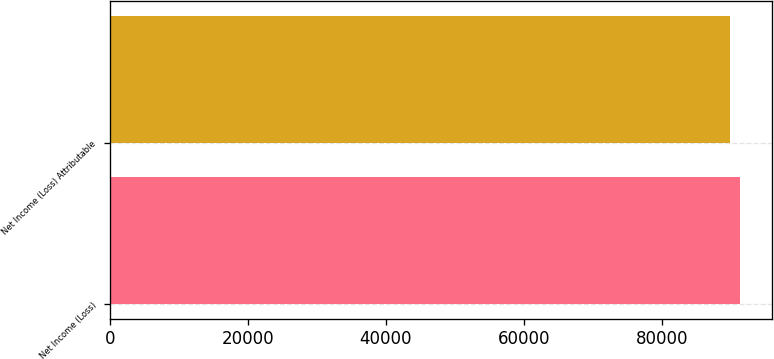<chart> <loc_0><loc_0><loc_500><loc_500><bar_chart><fcel>Net Income (Loss)<fcel>Net Income (Loss) Attributable<nl><fcel>91330<fcel>89901<nl></chart> 